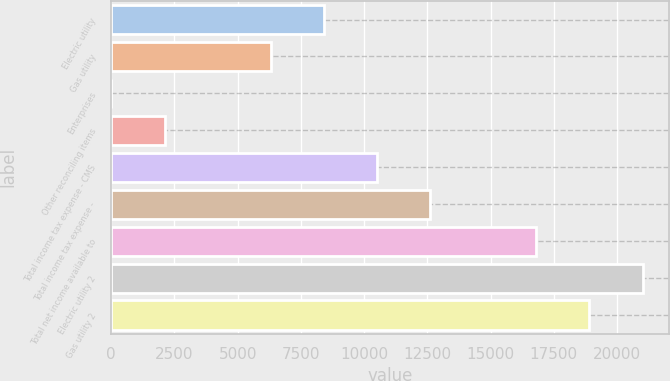Convert chart to OTSL. <chart><loc_0><loc_0><loc_500><loc_500><bar_chart><fcel>Electric utility<fcel>Gas utility<fcel>Enterprises<fcel>Other reconciling items<fcel>Total income tax expense - CMS<fcel>Total income tax expense -<fcel>Total net income available to<fcel>Electric utility 2<fcel>Gas utility 2<nl><fcel>8410<fcel>6310<fcel>10<fcel>2110<fcel>10510<fcel>12610<fcel>16810<fcel>21010<fcel>18910<nl></chart> 